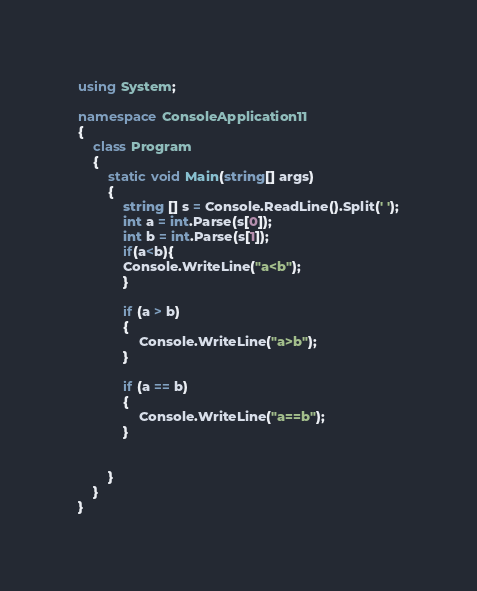Convert code to text. <code><loc_0><loc_0><loc_500><loc_500><_C#_>using System;

namespace ConsoleApplication11
{
    class Program
    {
        static void Main(string[] args)
        {
            string [] s = Console.ReadLine().Split(' ');
            int a = int.Parse(s[0]);
            int b = int.Parse(s[1]);
            if(a<b){
            Console.WriteLine("a<b");
            }

            if (a > b)
            {
                Console.WriteLine("a>b");
            }

            if (a == b)
            {
                Console.WriteLine("a==b");
            }

           
        }
    }
}</code> 